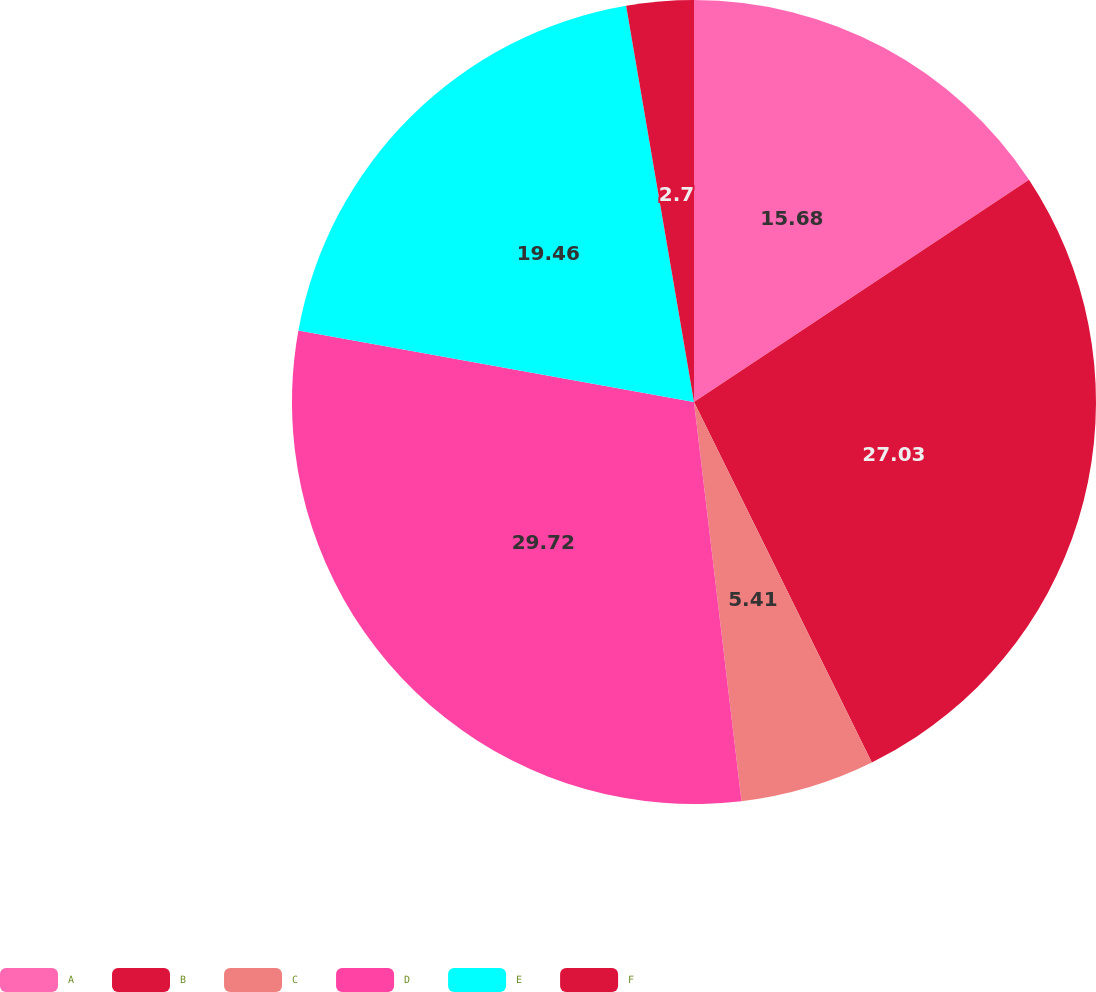<chart> <loc_0><loc_0><loc_500><loc_500><pie_chart><fcel>A<fcel>B<fcel>C<fcel>D<fcel>E<fcel>F<nl><fcel>15.68%<fcel>27.03%<fcel>5.41%<fcel>29.73%<fcel>19.46%<fcel>2.7%<nl></chart> 